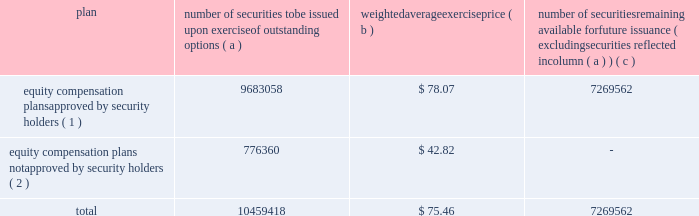Equity compensation plan information the table summarizes the equity compensation plan information as of december 31 , 2011 .
Information is included for equity compensation plans approved by the stockholders and equity compensation plans not approved by the stockholders .
Number of securities to be issued upon exercise of outstanding options weighted average exercise number of securities remaining available for future issuance ( excluding securities reflected in column ( a ) ) equity compensation plans approved by security holders ( 1 ) 9683058 $ 78.07 7269562 equity compensation plans not approved by security holders ( 2 ) 776360 $ 42.82 .
( 1 ) includes the equity ownership plan , which was approved by the shareholders on may 15 , 1998 , the 2007 equity ownership plan and the 2011 equity ownership plan .
The 2007 equity ownership plan was approved by entergy corporation shareholders on may 12 , 2006 , and 7000000 shares of entergy corporation common stock can be issued , with no more than 2000000 shares available for non-option grants .
The 2011 equity ownership plan was approved by entergy corporation shareholders on may 6 , 2011 , and 5500000 shares of entergy corporation common stock can be issued from the 2011 equity ownership plan , with no more than 2000000 shares available for incentive stock option grants .
The equity ownership plan , the 2007 equity ownership plan and the 2011 equity ownership plan ( the 201cplans 201d ) are administered by the personnel committee of the board of directors ( other than with respect to awards granted to non-employee directors , which awards are administered by the entire board of directors ) .
Eligibility under the plans is limited to the non-employee directors and to the officers and employees of an entergy system employer and any corporation 80% ( 80 % ) or more of whose stock ( based on voting power ) or value is owned , directly or indirectly , by entergy corporation .
The plans provide for the issuance of stock options , restricted shares , equity awards ( units whose value is related to the value of shares of the common stock but do not represent actual shares of common stock ) , performance awards ( performance shares or units valued by reference to shares of common stock or performance units valued by reference to financial measures or property other than common stock ) and other stock-based awards .
( 2 ) entergy has a board-approved stock-based compensation plan .
However , effective may 9 , 2003 , the board has directed that no further awards be issued under that plan .
Item 13 .
Certain relationships and related transactions and director independence for information regarding certain relationships , related transactions and director independence of entergy corporation , see the proxy statement under the headings 201ccorporate governance - director independence 201d and 201ctransactions with related persons , 201d which information is incorporated herein by reference .
Since december 31 , 2010 , none of the subsidiaries or any of their affiliates has participated in any transaction involving an amount in excess of $ 120000 in which any director or executive officer of any of the subsidiaries , any nominee for director , or any immediate family member of the foregoing had a material interest as contemplated by item 404 ( a ) of regulation s-k ( 201crelated party transactions 201d ) .
Entergy corporation 2019s board of directors has adopted written policies and procedures for the review , approval or ratification of related party transactions .
Under these policies and procedures , the corporate governance committee , or a subcommittee of the board of directors of entergy corporation composed of .
What portion of the total number of security options was not approved by security holders? 
Computations: (776360 / 10459418)
Answer: 0.07423. 